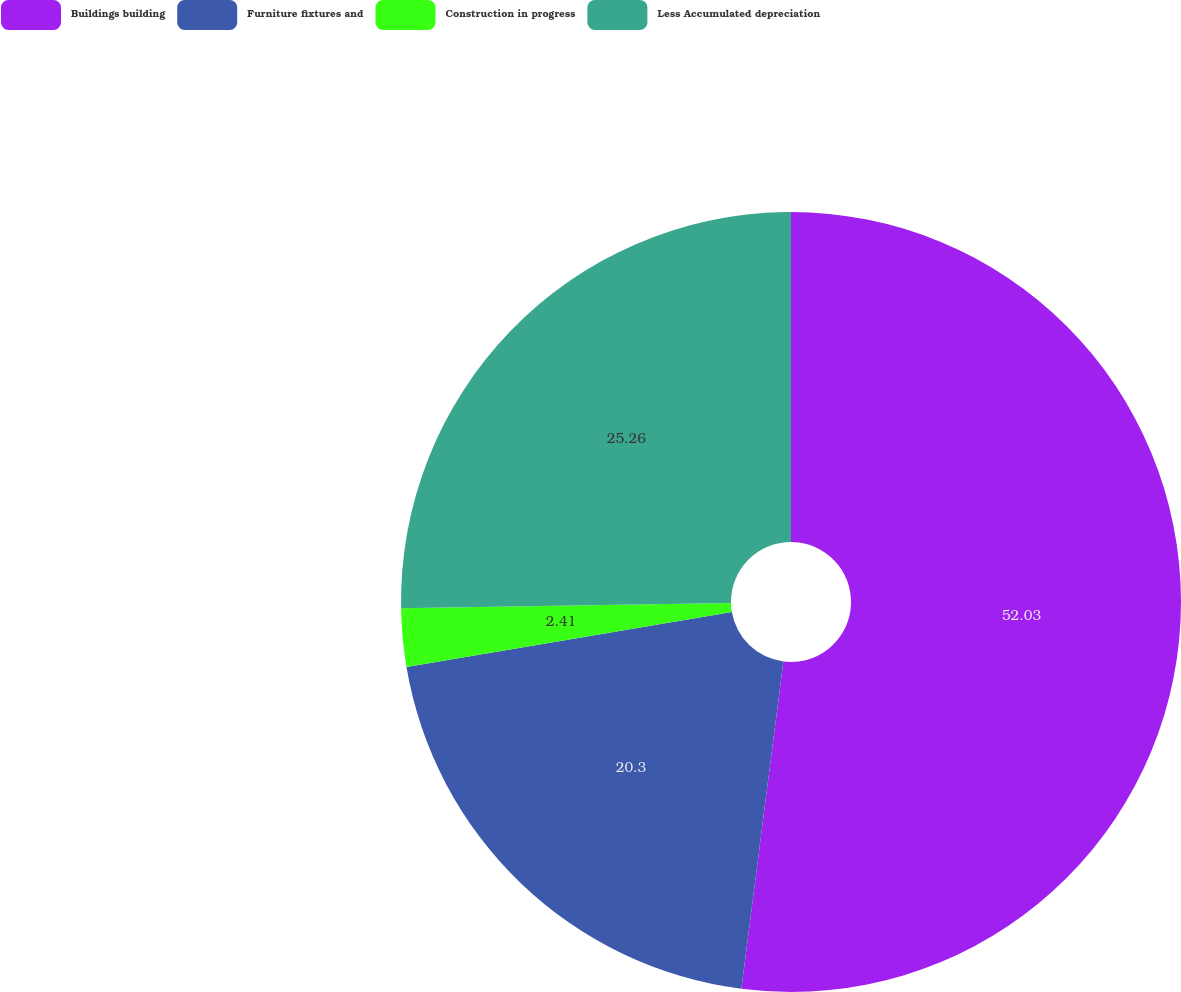Convert chart to OTSL. <chart><loc_0><loc_0><loc_500><loc_500><pie_chart><fcel>Buildings building<fcel>Furniture fixtures and<fcel>Construction in progress<fcel>Less Accumulated depreciation<nl><fcel>52.03%<fcel>20.3%<fcel>2.41%<fcel>25.26%<nl></chart> 